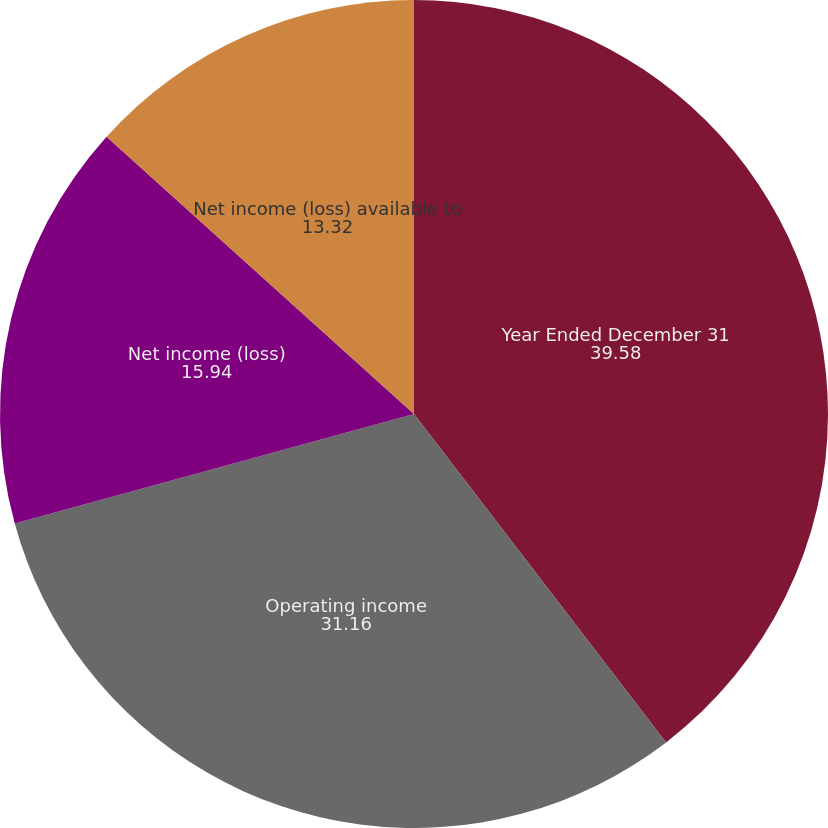Convert chart. <chart><loc_0><loc_0><loc_500><loc_500><pie_chart><fcel>Year Ended December 31<fcel>Operating income<fcel>Net income (loss)<fcel>Net income (loss) available to<nl><fcel>39.58%<fcel>31.16%<fcel>15.94%<fcel>13.32%<nl></chart> 